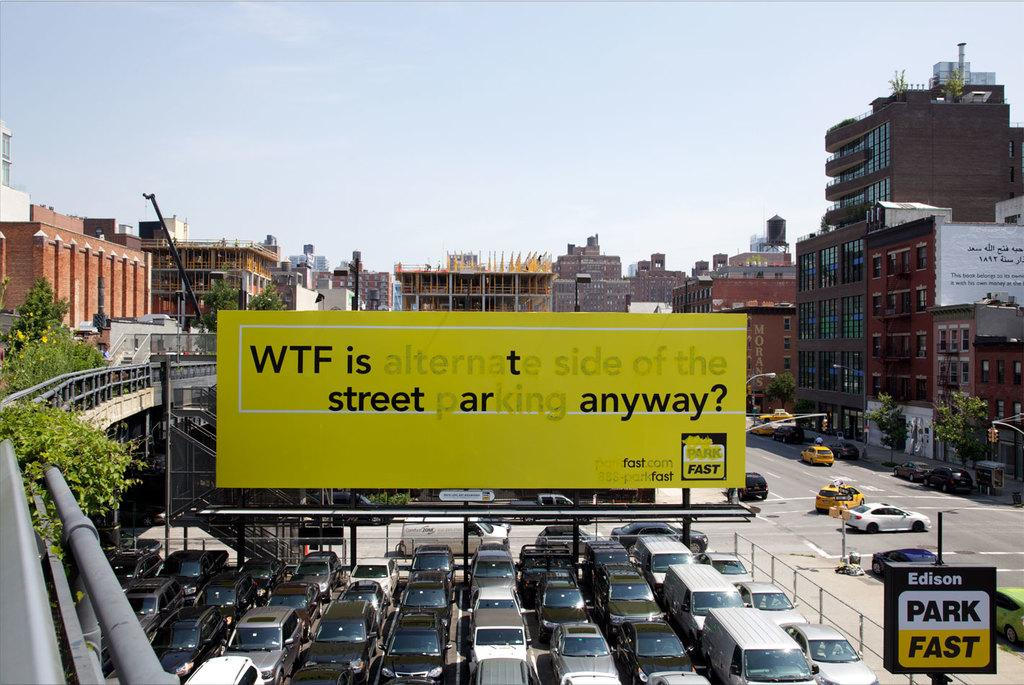<image>
Give a short and clear explanation of the subsequent image. A large yellow sign that asks wtf is alternate side of the street parking anyway. 